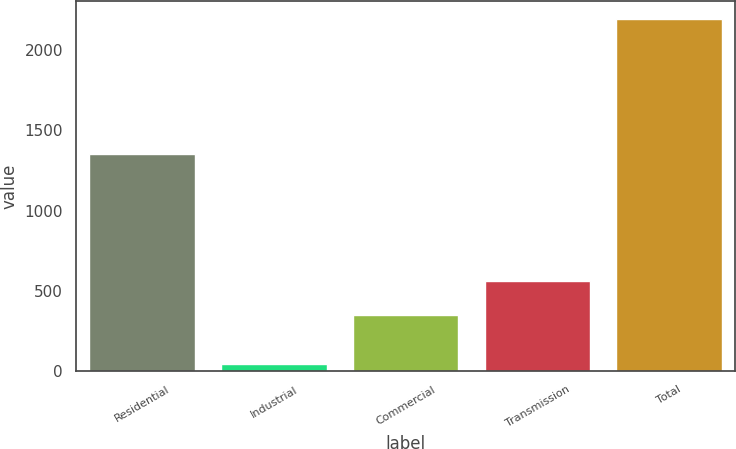Convert chart. <chart><loc_0><loc_0><loc_500><loc_500><bar_chart><fcel>Residential<fcel>Industrial<fcel>Commercial<fcel>Transmission<fcel>Total<nl><fcel>1351<fcel>44<fcel>349<fcel>564.1<fcel>2195<nl></chart> 